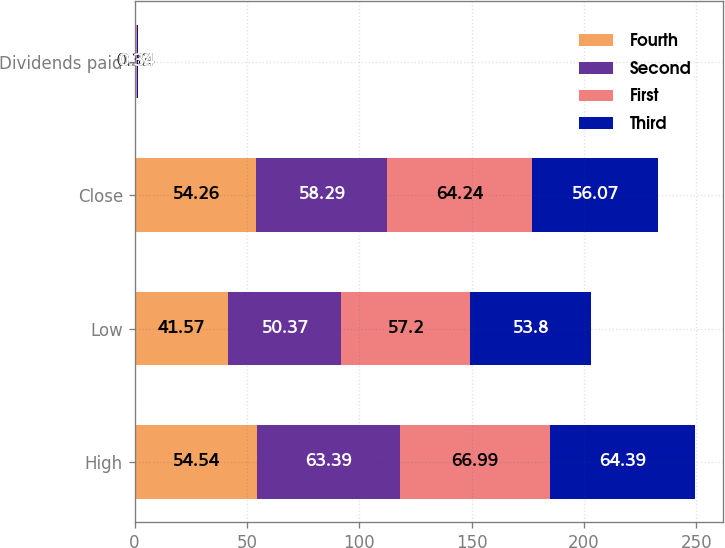<chart> <loc_0><loc_0><loc_500><loc_500><stacked_bar_chart><ecel><fcel>High<fcel>Low<fcel>Close<fcel>Dividends paid<nl><fcel>Fourth<fcel>54.54<fcel>41.57<fcel>54.26<fcel>0.33<nl><fcel>Second<fcel>63.39<fcel>50.37<fcel>58.29<fcel>0.33<nl><fcel>First<fcel>66.99<fcel>57.2<fcel>64.24<fcel>0.34<nl><fcel>Third<fcel>64.39<fcel>53.8<fcel>56.07<fcel>0.34<nl></chart> 